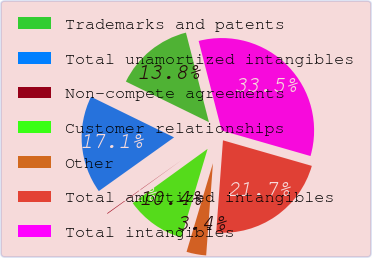Convert chart. <chart><loc_0><loc_0><loc_500><loc_500><pie_chart><fcel>Trademarks and patents<fcel>Total unamortized intangibles<fcel>Non-compete agreements<fcel>Customer relationships<fcel>Other<fcel>Total amortized intangibles<fcel>Total intangibles<nl><fcel>13.76%<fcel>17.1%<fcel>0.11%<fcel>10.42%<fcel>3.44%<fcel>21.71%<fcel>33.46%<nl></chart> 